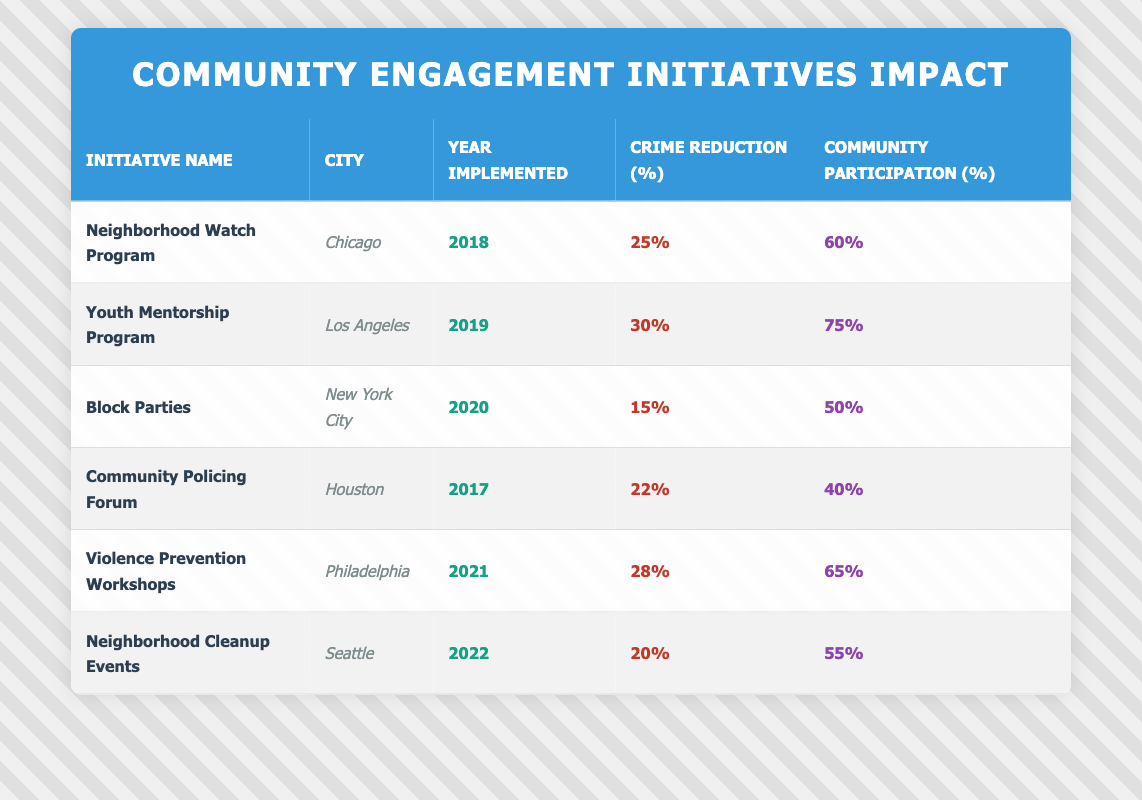What is the highest crime reduction percentage among the initiatives listed? The initiatives listed include varying crime reduction percentages. By inspecting the table, the "Youth Mentorship Program" shows a crime reduction percentage of 30%, which is the highest among all the initiatives.
Answer: 30% Which city implemented the "Neighborhood Cleanup Events"? The table indicates that the "Neighborhood Cleanup Events" were implemented in Seattle.
Answer: Seattle What is the community participation rate for the "Block Parties" initiative? According to the table, the "Block Parties" initiative has a community participation rate of 50%.
Answer: 50% Is the community participation rate for the "Community Policing Forum" higher than 50%? The table shows that the community participation rate for the "Community Policing Forum" is 40%, which is lower than 50%.
Answer: No What was the average crime reduction percentage across all initiatives? The crime reduction percentages are 25%, 30%, 15%, 22%, 28%, and 20%. First, sum them: 25 + 30 + 15 + 22 + 28 + 20 = 140. There are 6 initiatives, so the average is 140 / 6 = 23.33%.
Answer: 23.33% Which initiative had the lowest community participation rate, and what was that rate? The initiative with the lowest community participation rate can be found by reviewing the table for participation rates. The "Community Policing Forum" has the lowest rate at 40%.
Answer: Community Policing Forum, 40% How many initiatives were implemented in the year 2021? By examining the table, we see that "Violence Prevention Workshops" is the only initiative that was implemented in 2021. Therefore, there is just one initiative from that year.
Answer: 1 What is the difference in crime reduction percentage between the "Youth Mentorship Program" and the "Block Parties"? The "Youth Mentorship Program" has a crime reduction percentage of 30%, while the "Block Parties" has 15%. The difference is 30 - 15 = 15%.
Answer: 15% Was the community participation rate for the "Violence Prevention Workshops" higher than the average of all initiatives? The average community participation rate across all initiatives is (60 + 75 + 50 + 40 + 65 + 55) / 6 = 57.5%. The participation rate for "Violence Prevention Workshops" is 65%, which is higher than the average.
Answer: Yes 